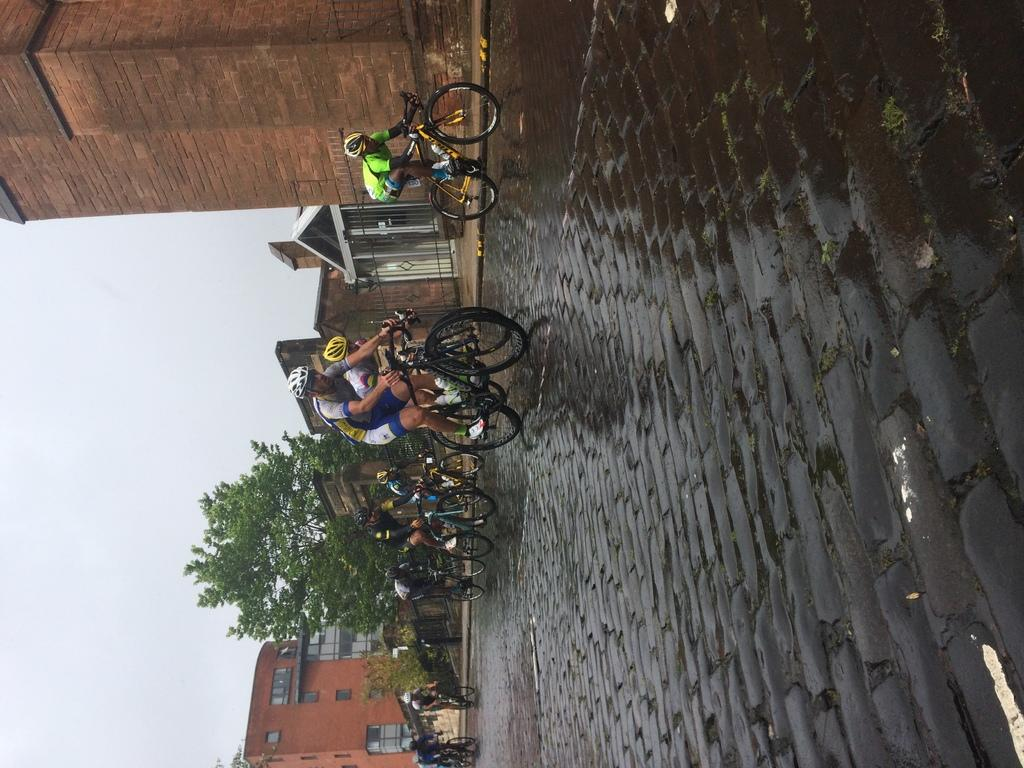What are the people in the image doing? The people in the image are riding bicycles. Where are the bicycles located? The bicycles are on the road. What can be seen in the background of the image? There is a tree, iron grilles, buildings, and the sky visible in the background. What type of quiver can be seen on the people riding bicycles in the image? There is no quiver present on the people riding bicycles in the image. What color is the button on the tree in the background? There is no button on the tree in the background, as trees do not have buttons. 